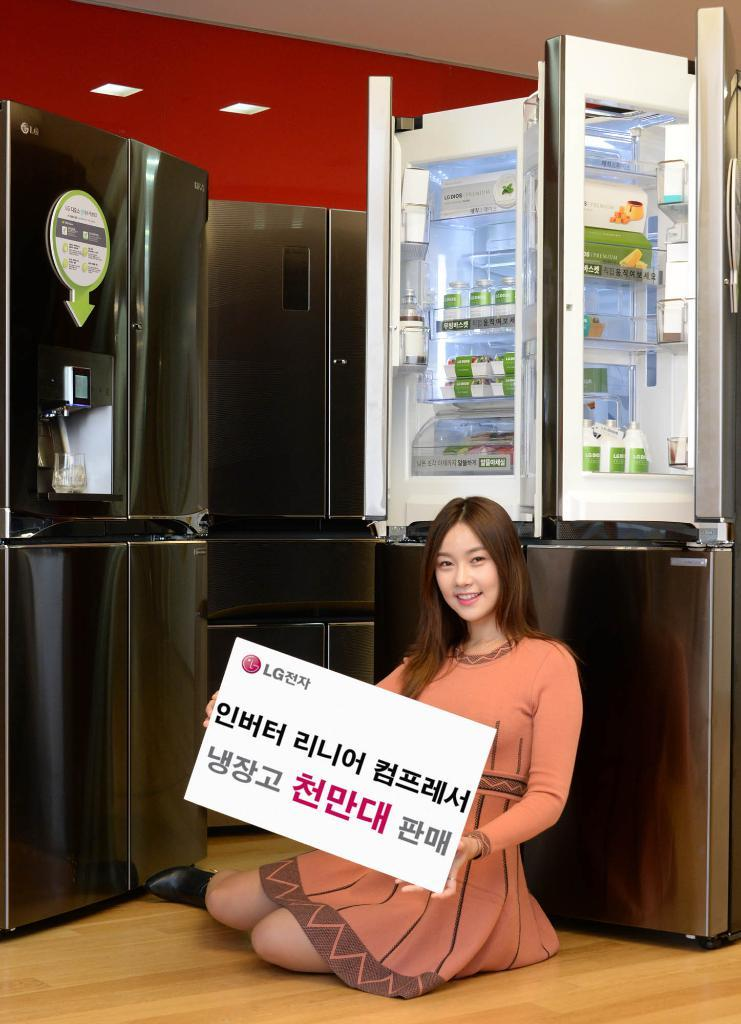What is present on the wall in the image? There is a wall in the image, but no specific details about the wall are provided. What type of appliances can be seen in the image? There are refrigerators in the image. What is the woman holding in the image? The woman is holding a banner in the image. Can you see any whips being used in the image? There is no mention of whips or any related activity in the image. What type of cloud can be seen in the image? There is no mention of clouds in the image. 